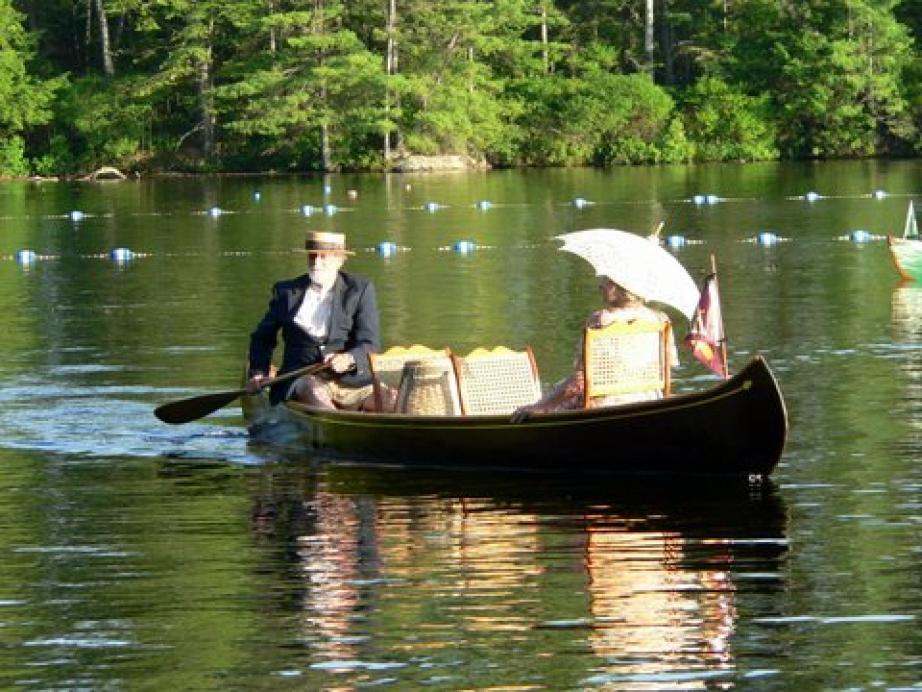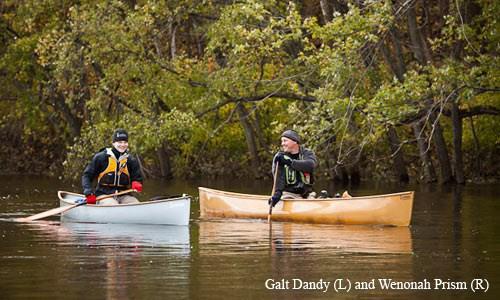The first image is the image on the left, the second image is the image on the right. Examine the images to the left and right. Is the description "There are no more than than two people in the image on the right." accurate? Answer yes or no. Yes. The first image is the image on the left, the second image is the image on the right. Evaluate the accuracy of this statement regarding the images: "Two canoes, each with one rider, are present in one image.". Is it true? Answer yes or no. Yes. 